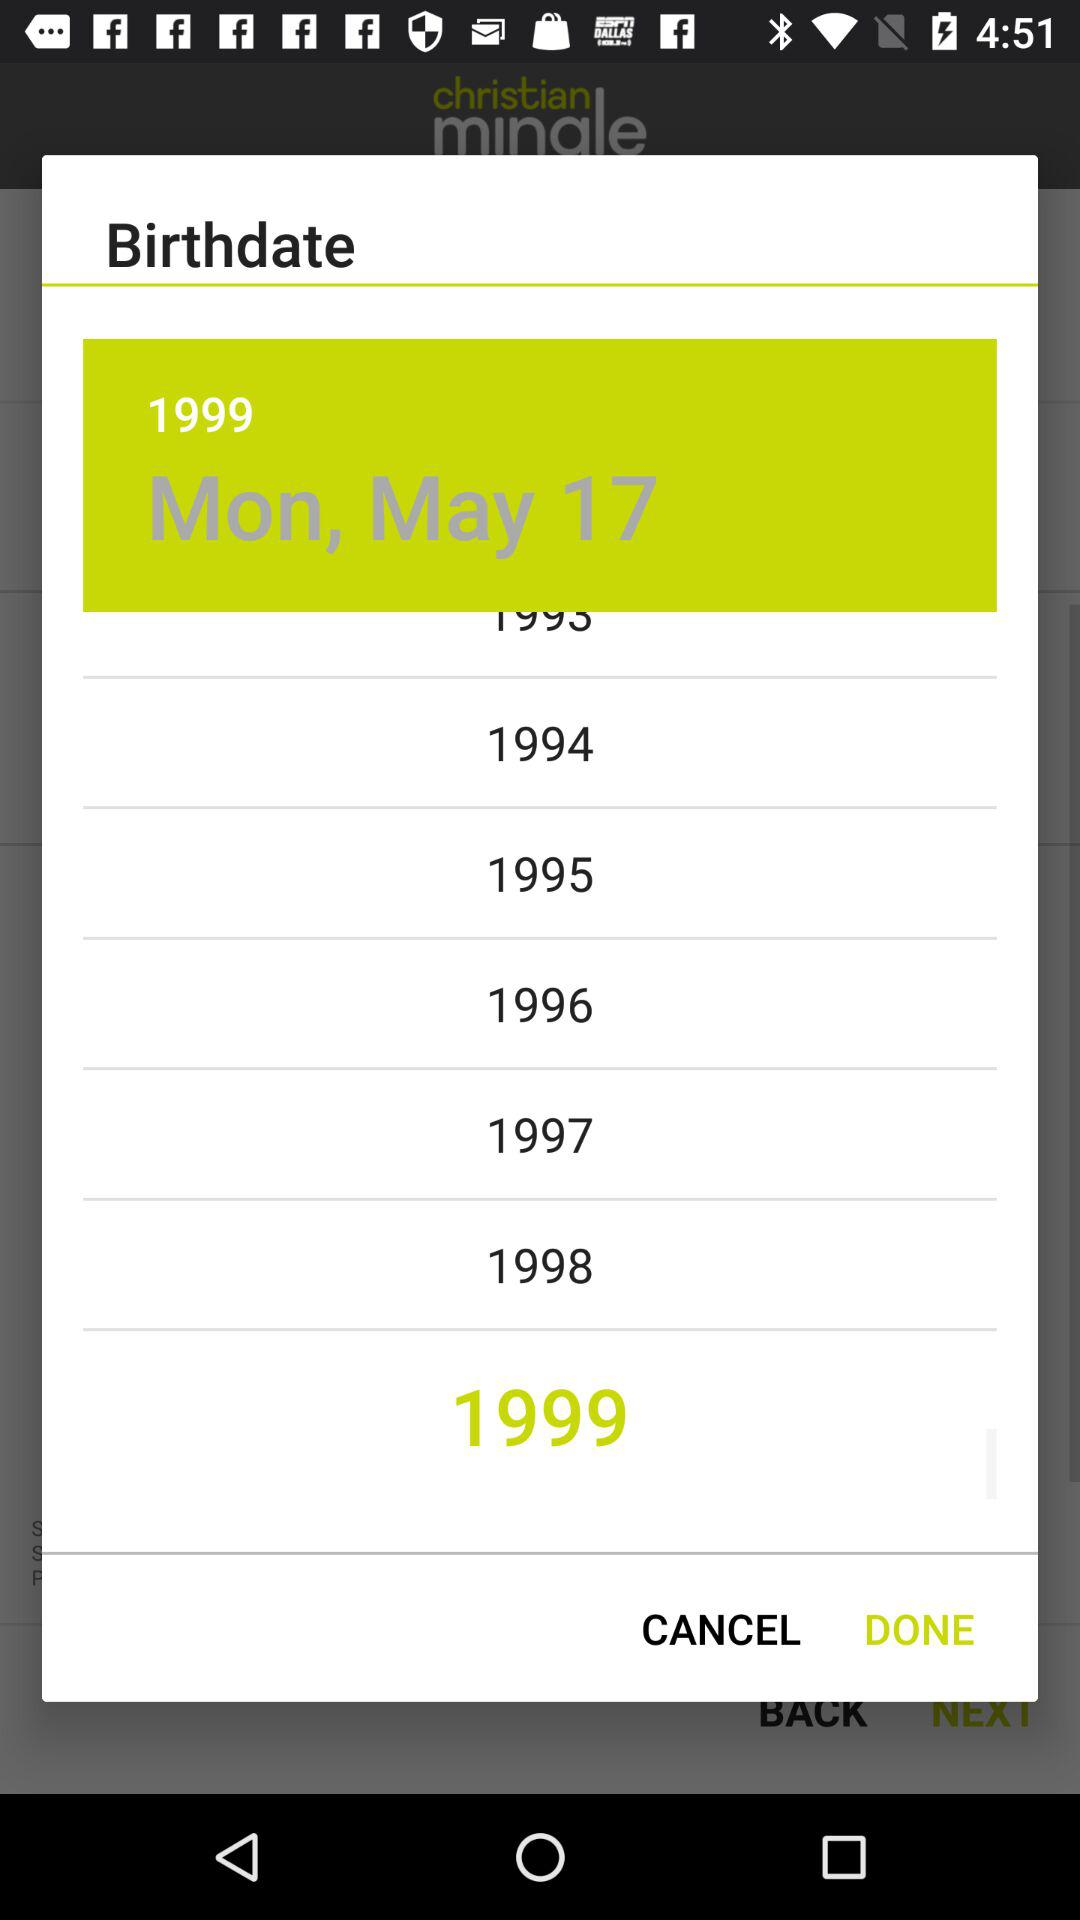What is the selected date? The selected date is Monday, May 17, 1999. 